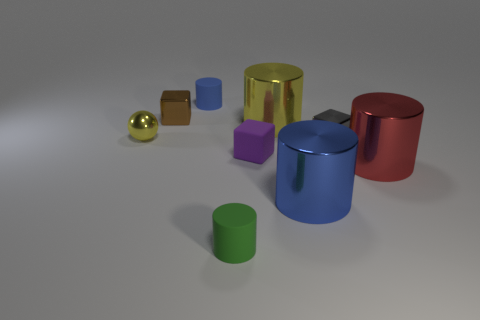How many other objects are the same shape as the large yellow metal thing?
Your answer should be very brief. 4. What number of brown things are either small metallic blocks or tiny metal spheres?
Your answer should be very brief. 1. Is the gray object the same shape as the large red thing?
Your response must be concise. No. There is a yellow shiny object to the right of the tiny green cylinder; is there a large yellow thing behind it?
Give a very brief answer. No. Is the number of small gray metal objects in front of the big blue object the same as the number of brown shiny objects?
Give a very brief answer. No. How many other objects are the same size as the red metallic cylinder?
Offer a very short reply. 2. Is the large cylinder that is to the left of the large blue metal cylinder made of the same material as the tiny cylinder that is behind the red cylinder?
Offer a terse response. No. What is the size of the blue thing in front of the yellow shiny thing that is left of the purple matte cube?
Ensure brevity in your answer.  Large. Are there any tiny things of the same color as the small ball?
Ensure brevity in your answer.  No. There is a shiny block that is in front of the yellow shiny ball; is its color the same as the small matte cylinder in front of the big yellow cylinder?
Make the answer very short. No. 